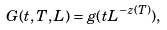Convert formula to latex. <formula><loc_0><loc_0><loc_500><loc_500>G ( t , T , L ) = g ( t L ^ { - z ( T ) } ) ,</formula> 